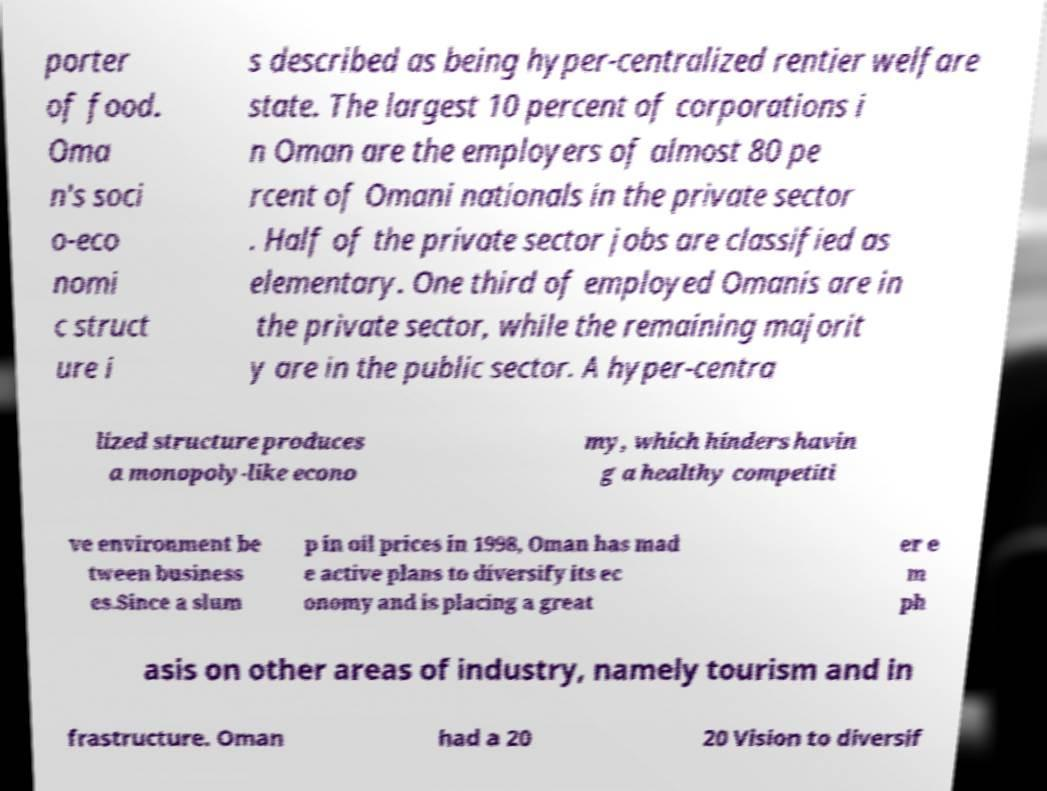I need the written content from this picture converted into text. Can you do that? porter of food. Oma n's soci o-eco nomi c struct ure i s described as being hyper-centralized rentier welfare state. The largest 10 percent of corporations i n Oman are the employers of almost 80 pe rcent of Omani nationals in the private sector . Half of the private sector jobs are classified as elementary. One third of employed Omanis are in the private sector, while the remaining majorit y are in the public sector. A hyper-centra lized structure produces a monopoly-like econo my, which hinders havin g a healthy competiti ve environment be tween business es.Since a slum p in oil prices in 1998, Oman has mad e active plans to diversify its ec onomy and is placing a great er e m ph asis on other areas of industry, namely tourism and in frastructure. Oman had a 20 20 Vision to diversif 